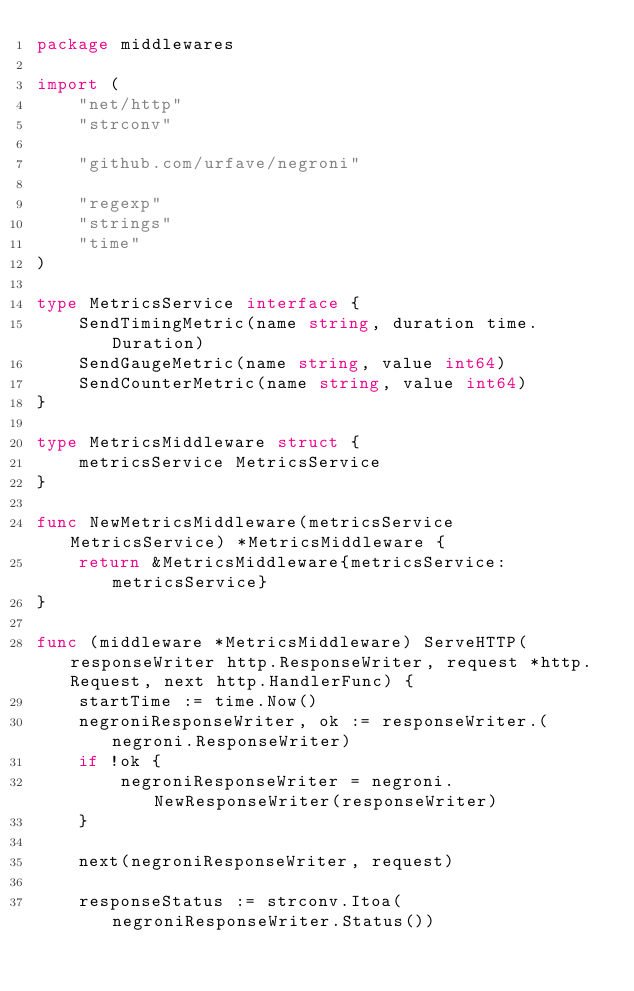<code> <loc_0><loc_0><loc_500><loc_500><_Go_>package middlewares

import (
	"net/http"
	"strconv"

	"github.com/urfave/negroni"

	"regexp"
	"strings"
	"time"
)

type MetricsService interface {
	SendTimingMetric(name string, duration time.Duration)
	SendGaugeMetric(name string, value int64)
	SendCounterMetric(name string, value int64)
}

type MetricsMiddleware struct {
	metricsService MetricsService
}

func NewMetricsMiddleware(metricsService MetricsService) *MetricsMiddleware {
	return &MetricsMiddleware{metricsService: metricsService}
}

func (middleware *MetricsMiddleware) ServeHTTP(responseWriter http.ResponseWriter, request *http.Request, next http.HandlerFunc) {
	startTime := time.Now()
	negroniResponseWriter, ok := responseWriter.(negroni.ResponseWriter)
	if !ok {
		negroniResponseWriter = negroni.NewResponseWriter(responseWriter)
	}

	next(negroniResponseWriter, request)

	responseStatus := strconv.Itoa(negroniResponseWriter.Status())</code> 